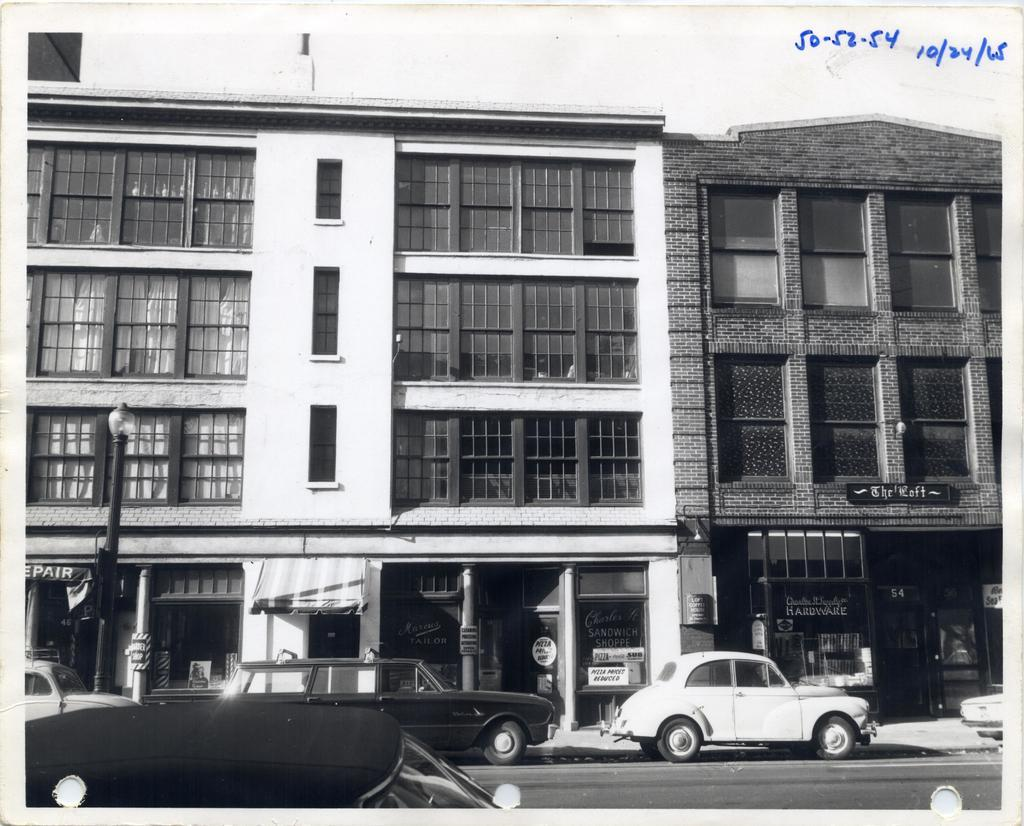What can be seen on the road in the image? There are vehicles on the road in the image. What is visible in the background of the image? There are buildings, a light pole, and boards in the background of the image. What is the purpose of the numbers at the top of the image? The purpose of the numbers at the top of the image is not clear from the provided facts. What arithmetic problem is being solved on the boards in the image? There is no arithmetic problem visible on the boards in the image. What type of offer is being made by the light pole in the image? The light pole is not making any offer in the image; it is a stationary object providing light. 